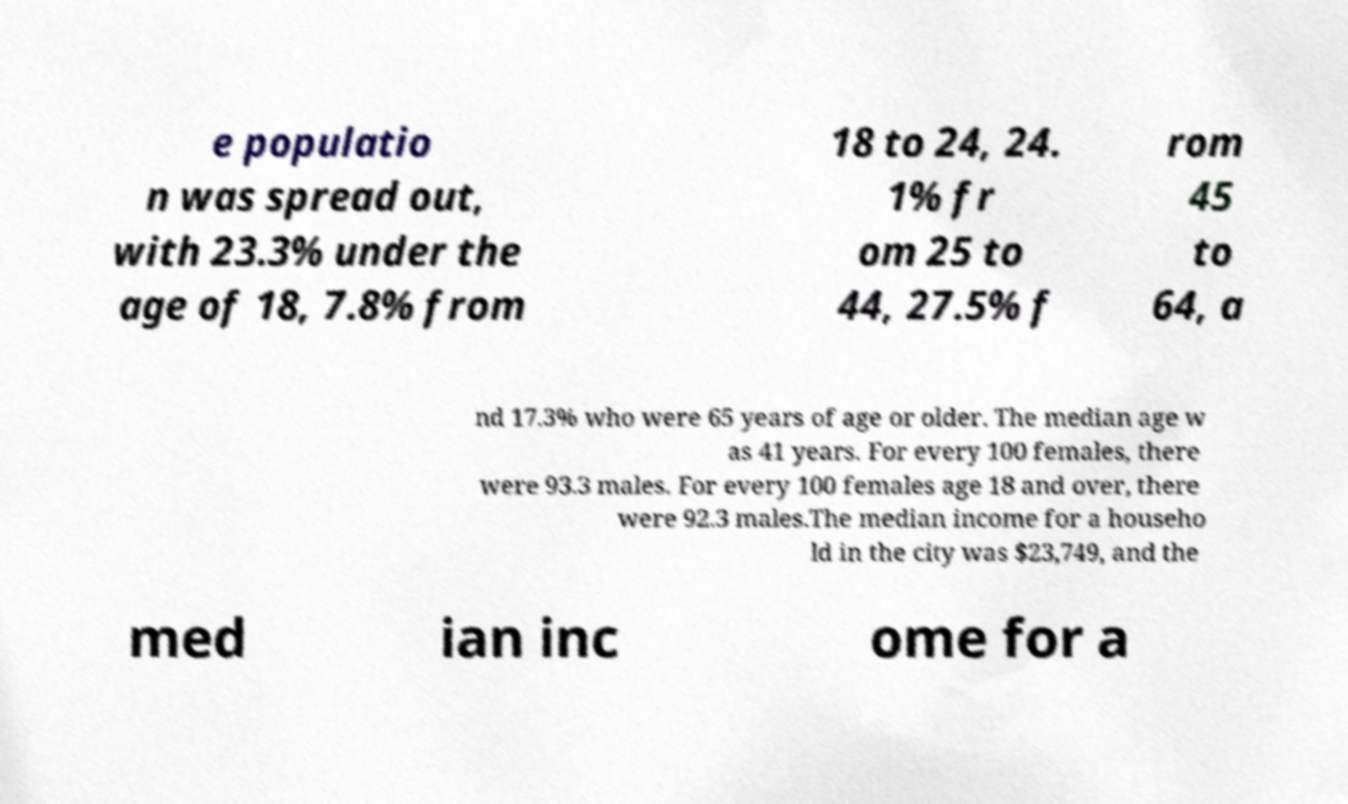For documentation purposes, I need the text within this image transcribed. Could you provide that? e populatio n was spread out, with 23.3% under the age of 18, 7.8% from 18 to 24, 24. 1% fr om 25 to 44, 27.5% f rom 45 to 64, a nd 17.3% who were 65 years of age or older. The median age w as 41 years. For every 100 females, there were 93.3 males. For every 100 females age 18 and over, there were 92.3 males.The median income for a househo ld in the city was $23,749, and the med ian inc ome for a 